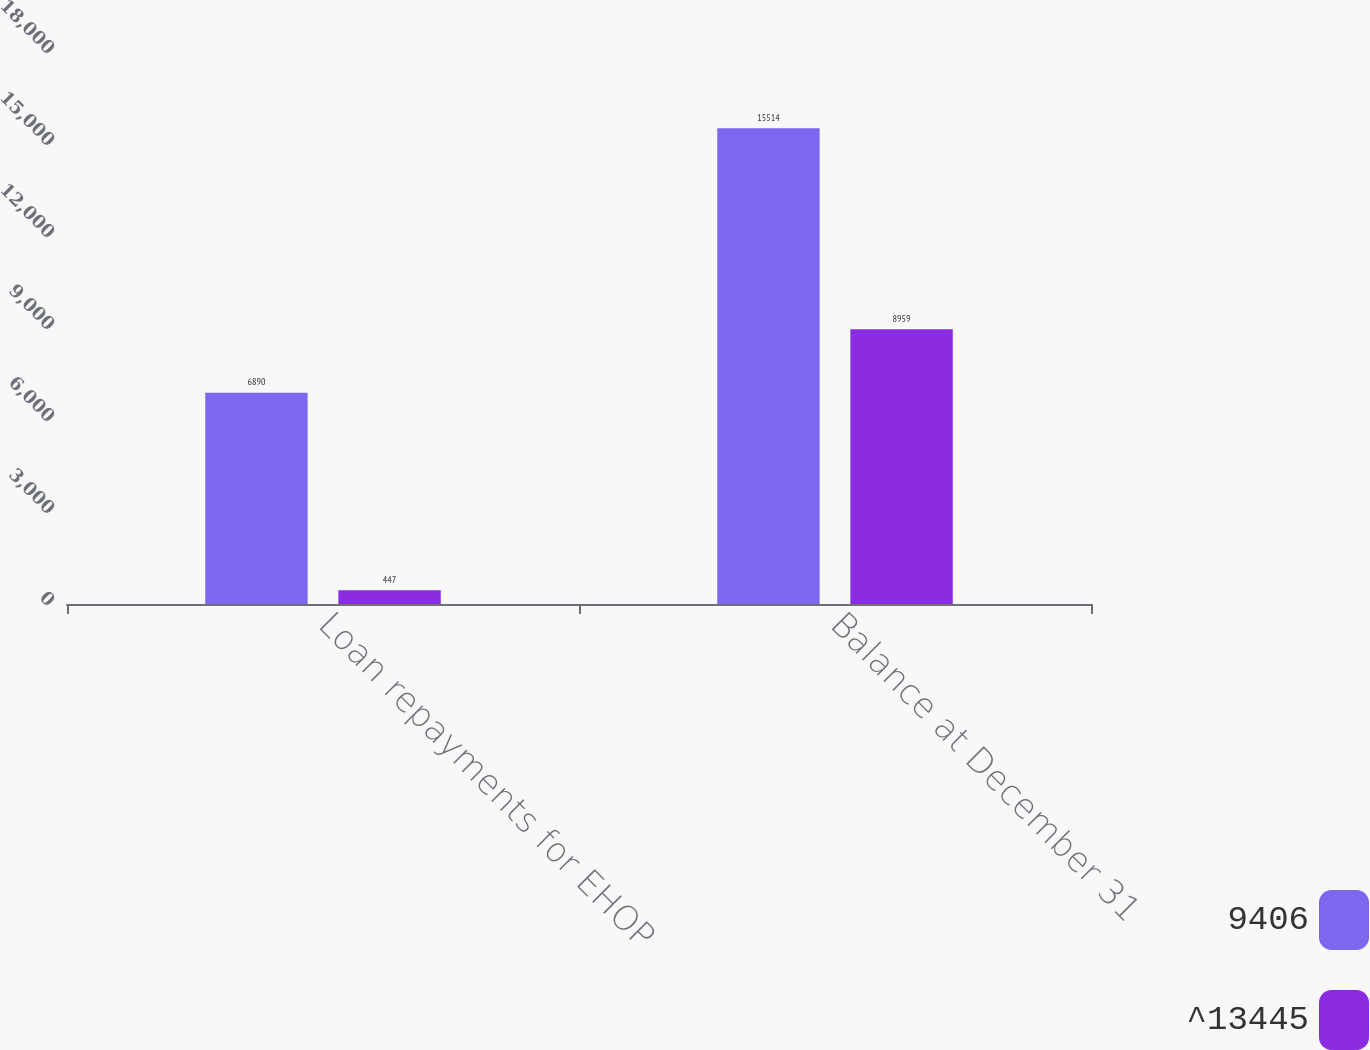Convert chart to OTSL. <chart><loc_0><loc_0><loc_500><loc_500><stacked_bar_chart><ecel><fcel>Loan repayments for EHOP<fcel>Balance at December 31<nl><fcel>9406<fcel>6890<fcel>15514<nl><fcel>^13445<fcel>447<fcel>8959<nl></chart> 